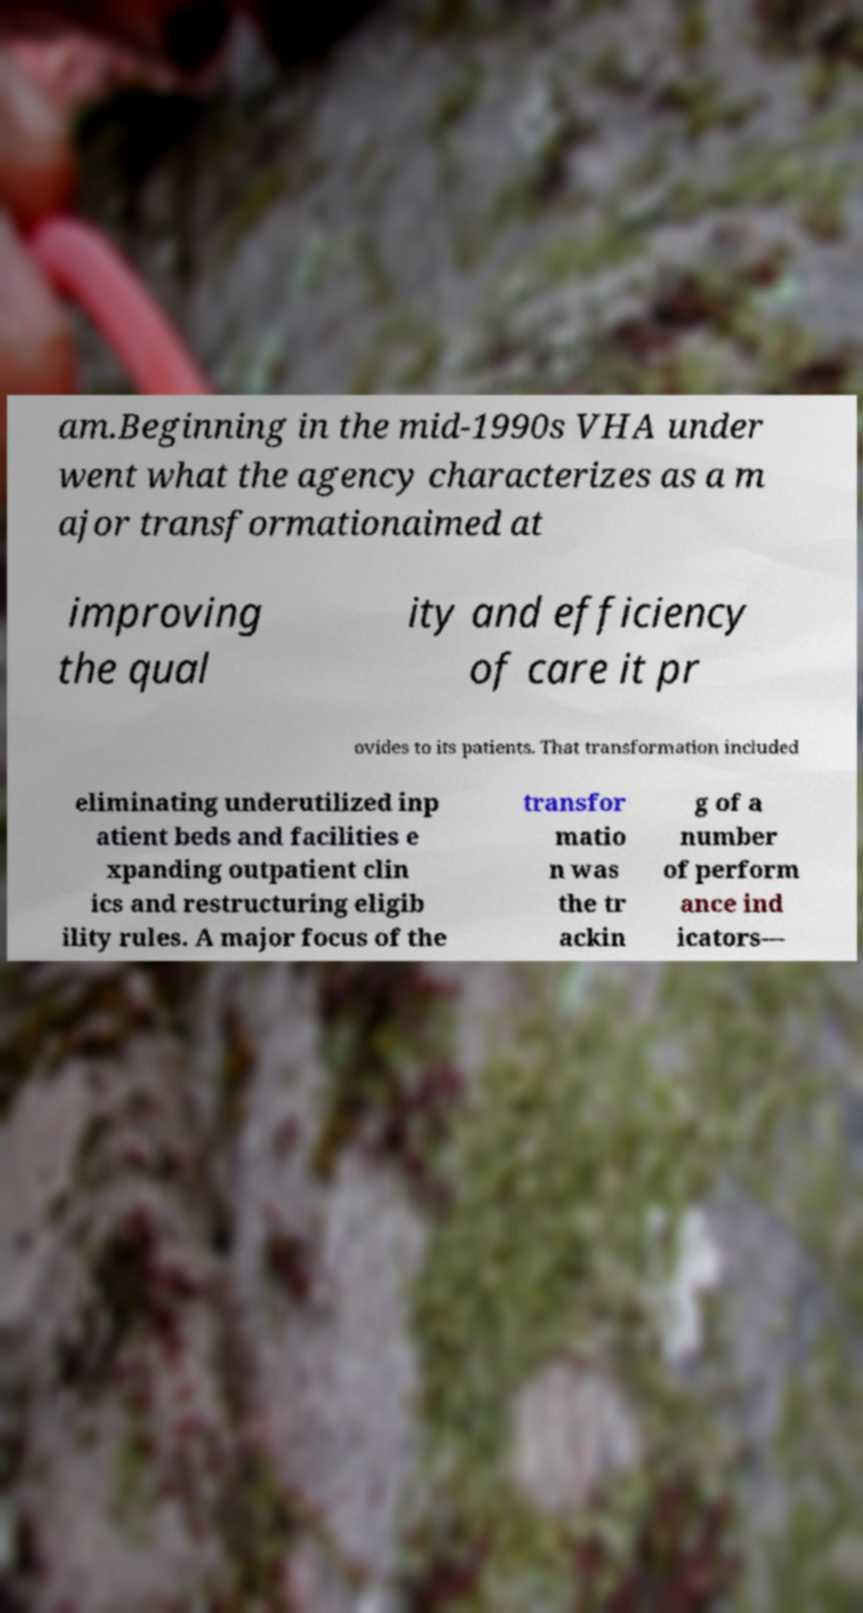For documentation purposes, I need the text within this image transcribed. Could you provide that? am.Beginning in the mid-1990s VHA under went what the agency characterizes as a m ajor transformationaimed at improving the qual ity and efficiency of care it pr ovides to its patients. That transformation included eliminating underutilized inp atient beds and facilities e xpanding outpatient clin ics and restructuring eligib ility rules. A major focus of the transfor matio n was the tr ackin g of a number of perform ance ind icators— 